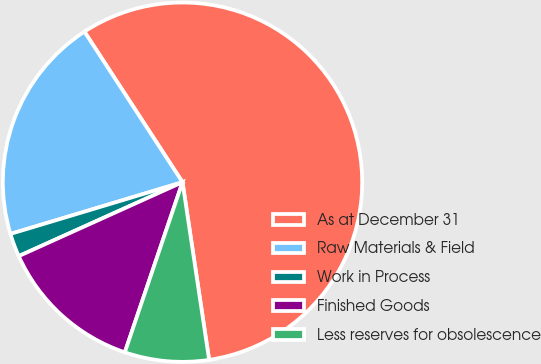Convert chart. <chart><loc_0><loc_0><loc_500><loc_500><pie_chart><fcel>As at December 31<fcel>Raw Materials & Field<fcel>Work in Process<fcel>Finished Goods<fcel>Less reserves for obsolescence<nl><fcel>56.83%<fcel>20.46%<fcel>2.1%<fcel>13.05%<fcel>7.57%<nl></chart> 